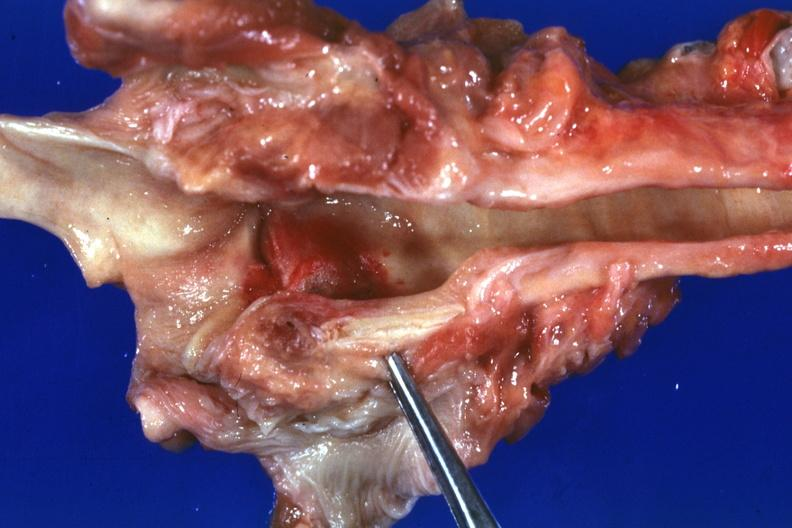where is this?
Answer the question using a single word or phrase. Oral 